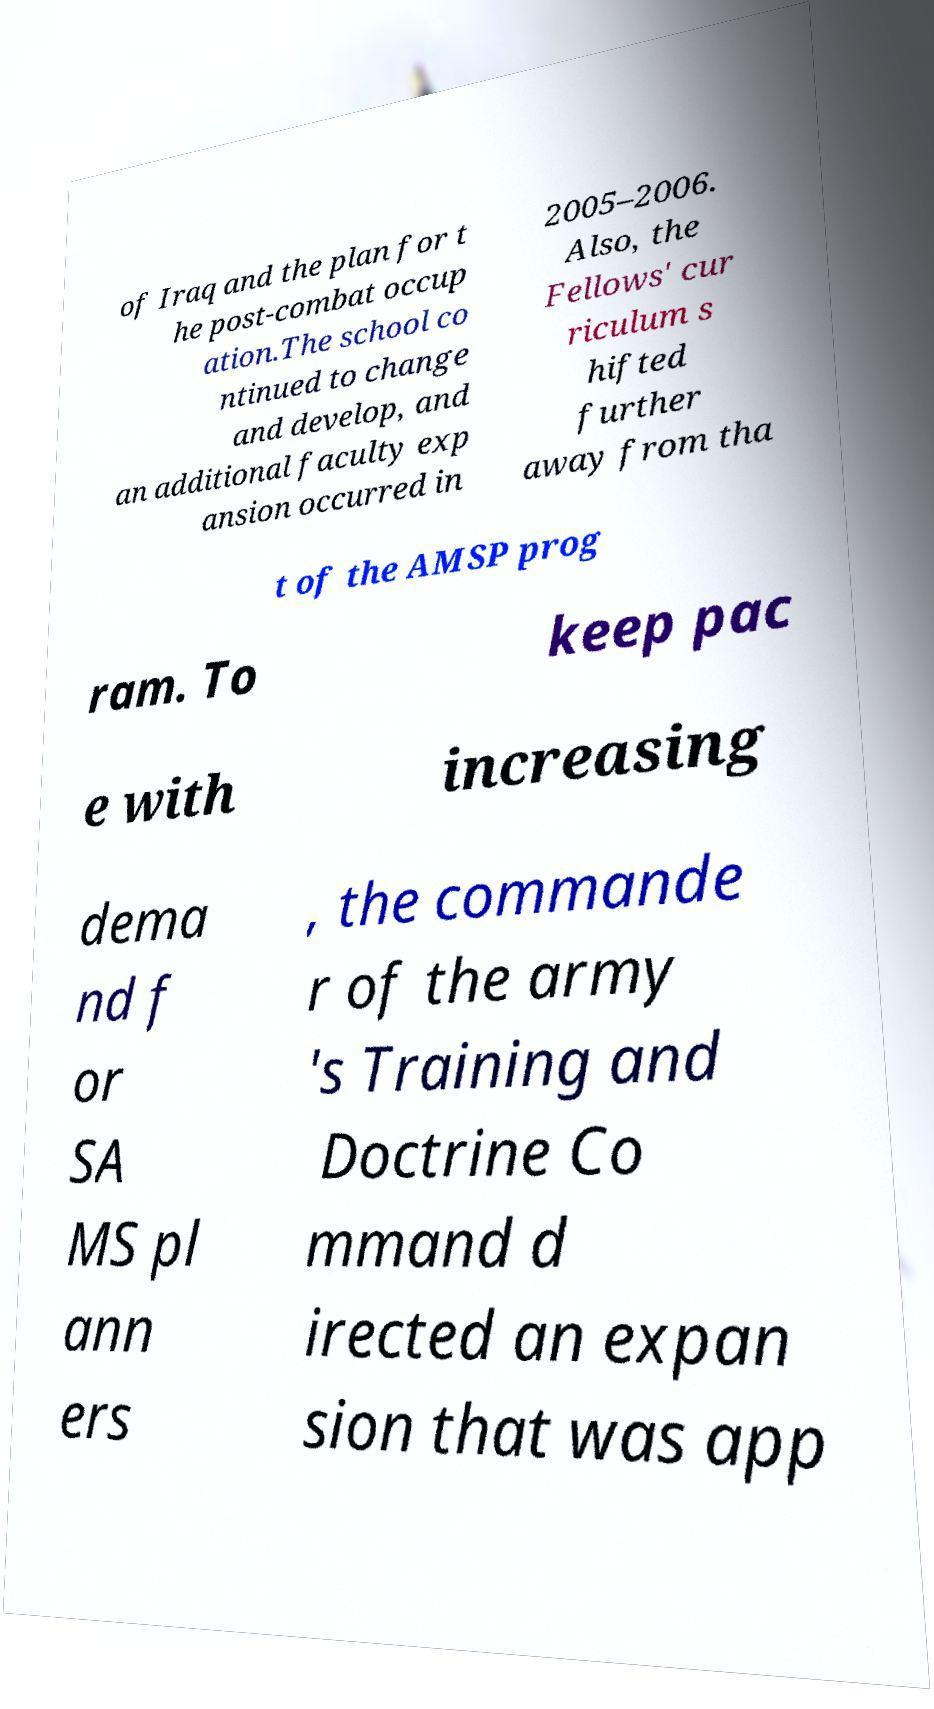Can you read and provide the text displayed in the image?This photo seems to have some interesting text. Can you extract and type it out for me? of Iraq and the plan for t he post-combat occup ation.The school co ntinued to change and develop, and an additional faculty exp ansion occurred in 2005–2006. Also, the Fellows' cur riculum s hifted further away from tha t of the AMSP prog ram. To keep pac e with increasing dema nd f or SA MS pl ann ers , the commande r of the army 's Training and Doctrine Co mmand d irected an expan sion that was app 